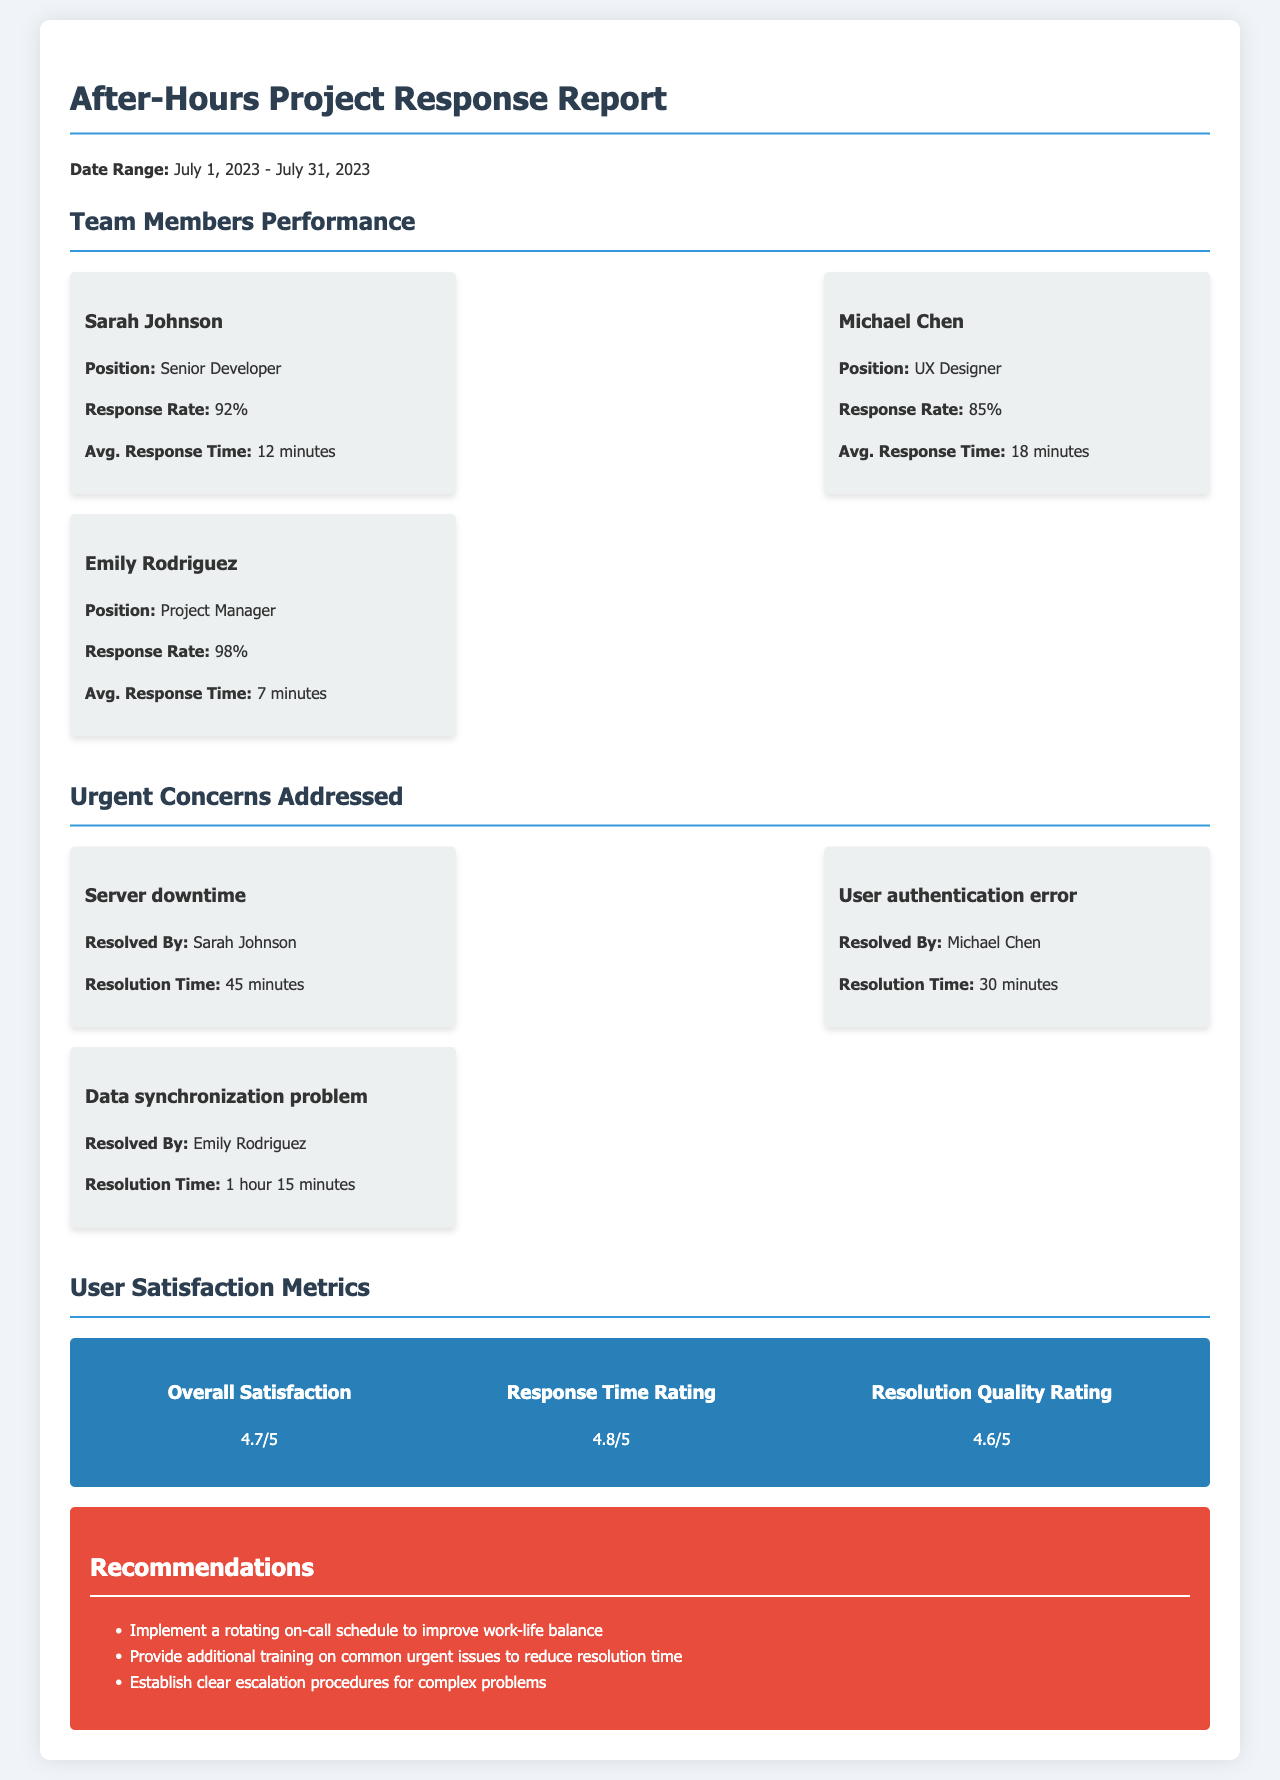What was the average response time of Emily Rodriguez? The average response time of Emily Rodriguez is found under her performance metrics.
Answer: 7 minutes What was the response rate of Sarah Johnson? The response rate is specified in the team members performance section for Sarah Johnson.
Answer: 92% How many urgent concerns were resolved by team members? The number of urgent concerns resolved can be counted from the concerns addressed section.
Answer: 3 What was the resolution time for the server downtime issue? The resolution time for server downtime is detailed in the urgent concerns addressed section.
Answer: 45 minutes What is the overall satisfaction rating? The overall satisfaction rating is provided in the user satisfaction metrics section.
Answer: 4.7/5 Which team member had the highest response rate? The highest response rate can be determined by comparing the response rates of all team members.
Answer: Emily Rodriguez What recommendation is made to improve work-life balance? The recommendation for improving work-life balance is mentioned in the recommendations section.
Answer: Implement a rotating on-call schedule How long did it take to resolve the data synchronization problem? The resolution time for the data synchronization problem is stated in the urgent concerns addressed section.
Answer: 1 hour 15 minutes What is the rating for response time? The rating for response time is listed in the user satisfaction metrics section.
Answer: 4.8/5 